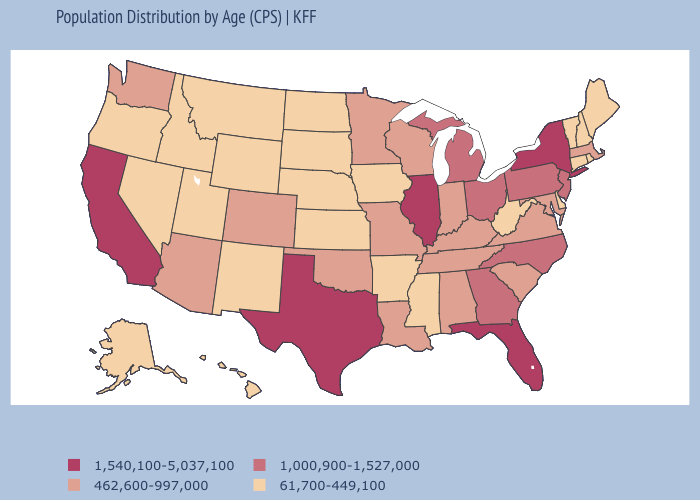Which states have the lowest value in the USA?
Keep it brief. Alaska, Arkansas, Connecticut, Delaware, Hawaii, Idaho, Iowa, Kansas, Maine, Mississippi, Montana, Nebraska, Nevada, New Hampshire, New Mexico, North Dakota, Oregon, Rhode Island, South Dakota, Utah, Vermont, West Virginia, Wyoming. Does the first symbol in the legend represent the smallest category?
Be succinct. No. Does Idaho have a lower value than Ohio?
Keep it brief. Yes. Among the states that border Rhode Island , which have the highest value?
Answer briefly. Massachusetts. What is the highest value in the MidWest ?
Give a very brief answer. 1,540,100-5,037,100. Does the first symbol in the legend represent the smallest category?
Keep it brief. No. Which states have the highest value in the USA?
Be succinct. California, Florida, Illinois, New York, Texas. Does Oregon have the highest value in the USA?
Concise answer only. No. What is the value of Alabama?
Keep it brief. 462,600-997,000. What is the value of Wyoming?
Answer briefly. 61,700-449,100. Which states have the lowest value in the USA?
Give a very brief answer. Alaska, Arkansas, Connecticut, Delaware, Hawaii, Idaho, Iowa, Kansas, Maine, Mississippi, Montana, Nebraska, Nevada, New Hampshire, New Mexico, North Dakota, Oregon, Rhode Island, South Dakota, Utah, Vermont, West Virginia, Wyoming. Does Nevada have the lowest value in the USA?
Keep it brief. Yes. Name the states that have a value in the range 1,000,900-1,527,000?
Keep it brief. Georgia, Michigan, New Jersey, North Carolina, Ohio, Pennsylvania. Does Iowa have a lower value than Tennessee?
Give a very brief answer. Yes. 